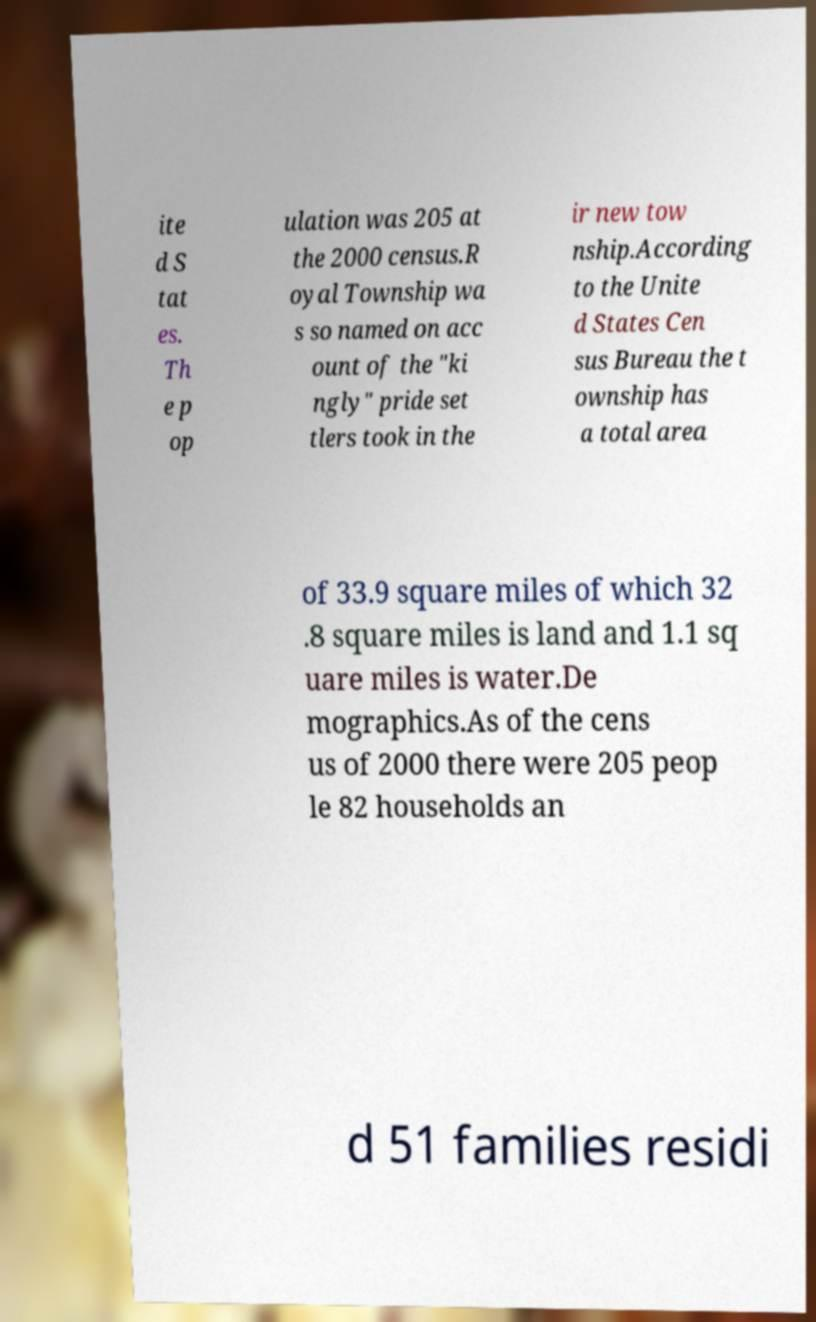Can you read and provide the text displayed in the image?This photo seems to have some interesting text. Can you extract and type it out for me? ite d S tat es. Th e p op ulation was 205 at the 2000 census.R oyal Township wa s so named on acc ount of the "ki ngly" pride set tlers took in the ir new tow nship.According to the Unite d States Cen sus Bureau the t ownship has a total area of 33.9 square miles of which 32 .8 square miles is land and 1.1 sq uare miles is water.De mographics.As of the cens us of 2000 there were 205 peop le 82 households an d 51 families residi 